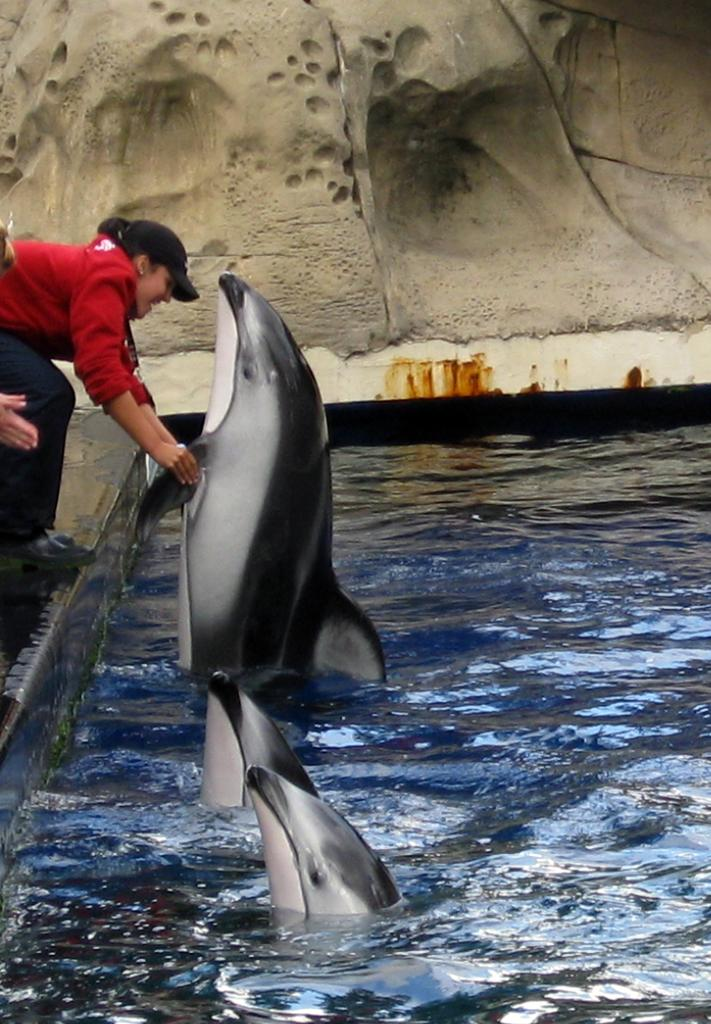What is the primary element in the image? The image consists of water. What animals can be seen in the water? There are dolphins in the water. Where is the person located in the image? The person is on the left side of the image. What is the person doing with the dolphin? The person is holding a dolphin. What type of lace is the person wearing on their shoes in the image? There is no mention of lace or shoes in the image; the person is holding a dolphin in the water. 